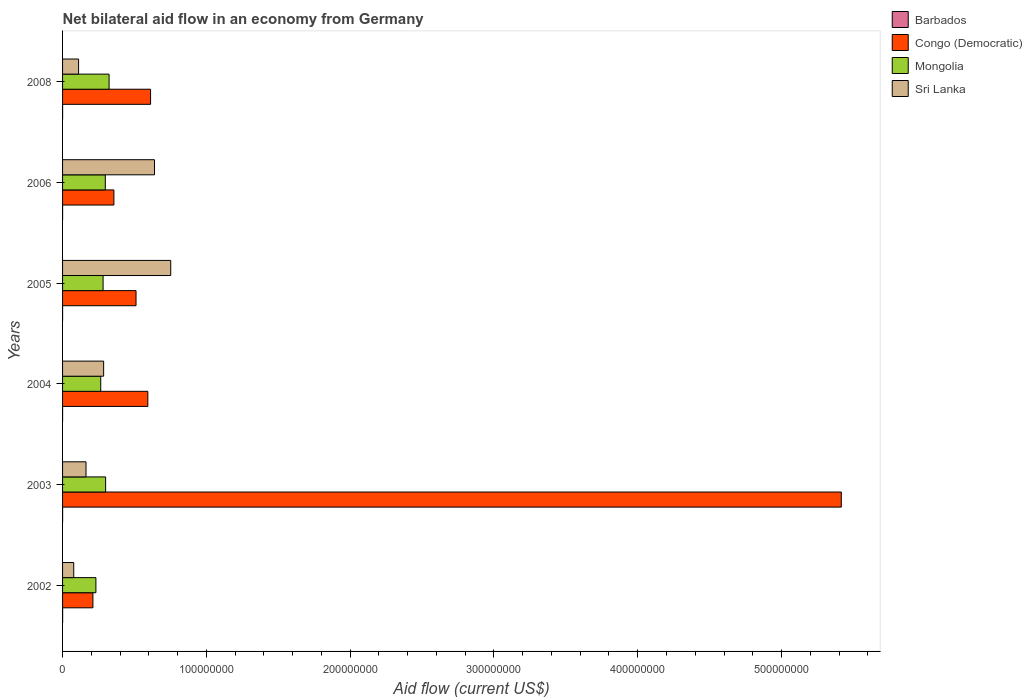How many different coloured bars are there?
Your response must be concise. 4. What is the net bilateral aid flow in Mongolia in 2004?
Keep it short and to the point. 2.65e+07. Across all years, what is the maximum net bilateral aid flow in Barbados?
Provide a succinct answer. 4.00e+04. Across all years, what is the minimum net bilateral aid flow in Congo (Democratic)?
Your answer should be compact. 2.11e+07. What is the total net bilateral aid flow in Mongolia in the graph?
Offer a very short reply. 1.70e+08. What is the difference between the net bilateral aid flow in Congo (Democratic) in 2005 and that in 2008?
Offer a very short reply. -1.01e+07. What is the difference between the net bilateral aid flow in Barbados in 2004 and the net bilateral aid flow in Congo (Democratic) in 2005?
Give a very brief answer. -5.11e+07. What is the average net bilateral aid flow in Sri Lanka per year?
Offer a very short reply. 3.38e+07. In the year 2006, what is the difference between the net bilateral aid flow in Mongolia and net bilateral aid flow in Barbados?
Your response must be concise. 2.97e+07. In how many years, is the net bilateral aid flow in Mongolia greater than 140000000 US$?
Keep it short and to the point. 0. What is the ratio of the net bilateral aid flow in Congo (Democratic) in 2004 to that in 2008?
Your response must be concise. 0.97. Is the net bilateral aid flow in Sri Lanka in 2003 less than that in 2004?
Offer a very short reply. Yes. Is the difference between the net bilateral aid flow in Mongolia in 2005 and 2008 greater than the difference between the net bilateral aid flow in Barbados in 2005 and 2008?
Give a very brief answer. No. What is the difference between the highest and the second highest net bilateral aid flow in Congo (Democratic)?
Keep it short and to the point. 4.80e+08. What is the difference between the highest and the lowest net bilateral aid flow in Mongolia?
Offer a terse response. 9.17e+06. In how many years, is the net bilateral aid flow in Barbados greater than the average net bilateral aid flow in Barbados taken over all years?
Keep it short and to the point. 2. Is it the case that in every year, the sum of the net bilateral aid flow in Congo (Democratic) and net bilateral aid flow in Mongolia is greater than the sum of net bilateral aid flow in Sri Lanka and net bilateral aid flow in Barbados?
Provide a short and direct response. Yes. What does the 3rd bar from the top in 2006 represents?
Keep it short and to the point. Congo (Democratic). What does the 1st bar from the bottom in 2002 represents?
Provide a succinct answer. Barbados. How many bars are there?
Provide a short and direct response. 24. How many years are there in the graph?
Provide a succinct answer. 6. Are the values on the major ticks of X-axis written in scientific E-notation?
Provide a succinct answer. No. Where does the legend appear in the graph?
Your answer should be compact. Top right. What is the title of the graph?
Make the answer very short. Net bilateral aid flow in an economy from Germany. What is the label or title of the X-axis?
Offer a very short reply. Aid flow (current US$). What is the Aid flow (current US$) in Barbados in 2002?
Give a very brief answer. 4.00e+04. What is the Aid flow (current US$) in Congo (Democratic) in 2002?
Ensure brevity in your answer.  2.11e+07. What is the Aid flow (current US$) of Mongolia in 2002?
Provide a succinct answer. 2.32e+07. What is the Aid flow (current US$) in Sri Lanka in 2002?
Provide a short and direct response. 7.77e+06. What is the Aid flow (current US$) of Congo (Democratic) in 2003?
Provide a short and direct response. 5.42e+08. What is the Aid flow (current US$) of Mongolia in 2003?
Your response must be concise. 2.99e+07. What is the Aid flow (current US$) in Sri Lanka in 2003?
Ensure brevity in your answer.  1.63e+07. What is the Aid flow (current US$) in Barbados in 2004?
Your response must be concise. 10000. What is the Aid flow (current US$) in Congo (Democratic) in 2004?
Offer a terse response. 5.93e+07. What is the Aid flow (current US$) in Mongolia in 2004?
Keep it short and to the point. 2.65e+07. What is the Aid flow (current US$) in Sri Lanka in 2004?
Give a very brief answer. 2.86e+07. What is the Aid flow (current US$) of Barbados in 2005?
Make the answer very short. 10000. What is the Aid flow (current US$) in Congo (Democratic) in 2005?
Keep it short and to the point. 5.11e+07. What is the Aid flow (current US$) of Mongolia in 2005?
Provide a short and direct response. 2.82e+07. What is the Aid flow (current US$) in Sri Lanka in 2005?
Your response must be concise. 7.52e+07. What is the Aid flow (current US$) of Congo (Democratic) in 2006?
Provide a succinct answer. 3.57e+07. What is the Aid flow (current US$) in Mongolia in 2006?
Offer a terse response. 2.97e+07. What is the Aid flow (current US$) in Sri Lanka in 2006?
Offer a very short reply. 6.39e+07. What is the Aid flow (current US$) of Congo (Democratic) in 2008?
Ensure brevity in your answer.  6.12e+07. What is the Aid flow (current US$) in Mongolia in 2008?
Your answer should be compact. 3.24e+07. What is the Aid flow (current US$) of Sri Lanka in 2008?
Provide a short and direct response. 1.11e+07. Across all years, what is the maximum Aid flow (current US$) of Congo (Democratic)?
Give a very brief answer. 5.42e+08. Across all years, what is the maximum Aid flow (current US$) of Mongolia?
Provide a succinct answer. 3.24e+07. Across all years, what is the maximum Aid flow (current US$) in Sri Lanka?
Your answer should be very brief. 7.52e+07. Across all years, what is the minimum Aid flow (current US$) of Barbados?
Your answer should be compact. 10000. Across all years, what is the minimum Aid flow (current US$) in Congo (Democratic)?
Provide a succinct answer. 2.11e+07. Across all years, what is the minimum Aid flow (current US$) of Mongolia?
Keep it short and to the point. 2.32e+07. Across all years, what is the minimum Aid flow (current US$) of Sri Lanka?
Give a very brief answer. 7.77e+06. What is the total Aid flow (current US$) in Congo (Democratic) in the graph?
Offer a terse response. 7.70e+08. What is the total Aid flow (current US$) of Mongolia in the graph?
Your response must be concise. 1.70e+08. What is the total Aid flow (current US$) of Sri Lanka in the graph?
Make the answer very short. 2.03e+08. What is the difference between the Aid flow (current US$) of Barbados in 2002 and that in 2003?
Give a very brief answer. 10000. What is the difference between the Aid flow (current US$) in Congo (Democratic) in 2002 and that in 2003?
Provide a succinct answer. -5.20e+08. What is the difference between the Aid flow (current US$) in Mongolia in 2002 and that in 2003?
Ensure brevity in your answer.  -6.75e+06. What is the difference between the Aid flow (current US$) of Sri Lanka in 2002 and that in 2003?
Your answer should be very brief. -8.54e+06. What is the difference between the Aid flow (current US$) of Congo (Democratic) in 2002 and that in 2004?
Ensure brevity in your answer.  -3.82e+07. What is the difference between the Aid flow (current US$) in Mongolia in 2002 and that in 2004?
Give a very brief answer. -3.35e+06. What is the difference between the Aid flow (current US$) of Sri Lanka in 2002 and that in 2004?
Your answer should be compact. -2.08e+07. What is the difference between the Aid flow (current US$) in Congo (Democratic) in 2002 and that in 2005?
Your answer should be compact. -3.00e+07. What is the difference between the Aid flow (current US$) of Mongolia in 2002 and that in 2005?
Offer a very short reply. -4.98e+06. What is the difference between the Aid flow (current US$) in Sri Lanka in 2002 and that in 2005?
Your response must be concise. -6.75e+07. What is the difference between the Aid flow (current US$) of Congo (Democratic) in 2002 and that in 2006?
Give a very brief answer. -1.46e+07. What is the difference between the Aid flow (current US$) in Mongolia in 2002 and that in 2006?
Offer a very short reply. -6.54e+06. What is the difference between the Aid flow (current US$) in Sri Lanka in 2002 and that in 2006?
Make the answer very short. -5.62e+07. What is the difference between the Aid flow (current US$) of Congo (Democratic) in 2002 and that in 2008?
Give a very brief answer. -4.01e+07. What is the difference between the Aid flow (current US$) in Mongolia in 2002 and that in 2008?
Make the answer very short. -9.17e+06. What is the difference between the Aid flow (current US$) in Sri Lanka in 2002 and that in 2008?
Ensure brevity in your answer.  -3.37e+06. What is the difference between the Aid flow (current US$) in Congo (Democratic) in 2003 and that in 2004?
Offer a very short reply. 4.82e+08. What is the difference between the Aid flow (current US$) in Mongolia in 2003 and that in 2004?
Provide a short and direct response. 3.40e+06. What is the difference between the Aid flow (current US$) in Sri Lanka in 2003 and that in 2004?
Give a very brief answer. -1.23e+07. What is the difference between the Aid flow (current US$) of Barbados in 2003 and that in 2005?
Offer a terse response. 2.00e+04. What is the difference between the Aid flow (current US$) in Congo (Democratic) in 2003 and that in 2005?
Keep it short and to the point. 4.90e+08. What is the difference between the Aid flow (current US$) in Mongolia in 2003 and that in 2005?
Provide a short and direct response. 1.77e+06. What is the difference between the Aid flow (current US$) of Sri Lanka in 2003 and that in 2005?
Make the answer very short. -5.89e+07. What is the difference between the Aid flow (current US$) in Congo (Democratic) in 2003 and that in 2006?
Provide a succinct answer. 5.06e+08. What is the difference between the Aid flow (current US$) of Mongolia in 2003 and that in 2006?
Provide a succinct answer. 2.10e+05. What is the difference between the Aid flow (current US$) in Sri Lanka in 2003 and that in 2006?
Keep it short and to the point. -4.76e+07. What is the difference between the Aid flow (current US$) in Congo (Democratic) in 2003 and that in 2008?
Keep it short and to the point. 4.80e+08. What is the difference between the Aid flow (current US$) in Mongolia in 2003 and that in 2008?
Keep it short and to the point. -2.42e+06. What is the difference between the Aid flow (current US$) in Sri Lanka in 2003 and that in 2008?
Offer a terse response. 5.17e+06. What is the difference between the Aid flow (current US$) of Barbados in 2004 and that in 2005?
Keep it short and to the point. 0. What is the difference between the Aid flow (current US$) in Congo (Democratic) in 2004 and that in 2005?
Your response must be concise. 8.20e+06. What is the difference between the Aid flow (current US$) of Mongolia in 2004 and that in 2005?
Provide a short and direct response. -1.63e+06. What is the difference between the Aid flow (current US$) in Sri Lanka in 2004 and that in 2005?
Offer a very short reply. -4.67e+07. What is the difference between the Aid flow (current US$) in Congo (Democratic) in 2004 and that in 2006?
Give a very brief answer. 2.36e+07. What is the difference between the Aid flow (current US$) in Mongolia in 2004 and that in 2006?
Keep it short and to the point. -3.19e+06. What is the difference between the Aid flow (current US$) in Sri Lanka in 2004 and that in 2006?
Keep it short and to the point. -3.54e+07. What is the difference between the Aid flow (current US$) in Barbados in 2004 and that in 2008?
Your response must be concise. -10000. What is the difference between the Aid flow (current US$) of Congo (Democratic) in 2004 and that in 2008?
Provide a succinct answer. -1.92e+06. What is the difference between the Aid flow (current US$) in Mongolia in 2004 and that in 2008?
Make the answer very short. -5.82e+06. What is the difference between the Aid flow (current US$) of Sri Lanka in 2004 and that in 2008?
Give a very brief answer. 1.74e+07. What is the difference between the Aid flow (current US$) in Barbados in 2005 and that in 2006?
Give a very brief answer. -10000. What is the difference between the Aid flow (current US$) of Congo (Democratic) in 2005 and that in 2006?
Keep it short and to the point. 1.54e+07. What is the difference between the Aid flow (current US$) of Mongolia in 2005 and that in 2006?
Keep it short and to the point. -1.56e+06. What is the difference between the Aid flow (current US$) in Sri Lanka in 2005 and that in 2006?
Keep it short and to the point. 1.13e+07. What is the difference between the Aid flow (current US$) in Congo (Democratic) in 2005 and that in 2008?
Give a very brief answer. -1.01e+07. What is the difference between the Aid flow (current US$) in Mongolia in 2005 and that in 2008?
Provide a short and direct response. -4.19e+06. What is the difference between the Aid flow (current US$) in Sri Lanka in 2005 and that in 2008?
Give a very brief answer. 6.41e+07. What is the difference between the Aid flow (current US$) of Congo (Democratic) in 2006 and that in 2008?
Your answer should be compact. -2.55e+07. What is the difference between the Aid flow (current US$) of Mongolia in 2006 and that in 2008?
Offer a terse response. -2.63e+06. What is the difference between the Aid flow (current US$) in Sri Lanka in 2006 and that in 2008?
Give a very brief answer. 5.28e+07. What is the difference between the Aid flow (current US$) in Barbados in 2002 and the Aid flow (current US$) in Congo (Democratic) in 2003?
Provide a short and direct response. -5.42e+08. What is the difference between the Aid flow (current US$) in Barbados in 2002 and the Aid flow (current US$) in Mongolia in 2003?
Your answer should be compact. -2.99e+07. What is the difference between the Aid flow (current US$) of Barbados in 2002 and the Aid flow (current US$) of Sri Lanka in 2003?
Ensure brevity in your answer.  -1.63e+07. What is the difference between the Aid flow (current US$) of Congo (Democratic) in 2002 and the Aid flow (current US$) of Mongolia in 2003?
Provide a succinct answer. -8.83e+06. What is the difference between the Aid flow (current US$) in Congo (Democratic) in 2002 and the Aid flow (current US$) in Sri Lanka in 2003?
Ensure brevity in your answer.  4.80e+06. What is the difference between the Aid flow (current US$) in Mongolia in 2002 and the Aid flow (current US$) in Sri Lanka in 2003?
Provide a short and direct response. 6.88e+06. What is the difference between the Aid flow (current US$) in Barbados in 2002 and the Aid flow (current US$) in Congo (Democratic) in 2004?
Your answer should be compact. -5.92e+07. What is the difference between the Aid flow (current US$) of Barbados in 2002 and the Aid flow (current US$) of Mongolia in 2004?
Ensure brevity in your answer.  -2.65e+07. What is the difference between the Aid flow (current US$) in Barbados in 2002 and the Aid flow (current US$) in Sri Lanka in 2004?
Provide a succinct answer. -2.85e+07. What is the difference between the Aid flow (current US$) in Congo (Democratic) in 2002 and the Aid flow (current US$) in Mongolia in 2004?
Offer a terse response. -5.43e+06. What is the difference between the Aid flow (current US$) of Congo (Democratic) in 2002 and the Aid flow (current US$) of Sri Lanka in 2004?
Provide a short and direct response. -7.46e+06. What is the difference between the Aid flow (current US$) of Mongolia in 2002 and the Aid flow (current US$) of Sri Lanka in 2004?
Your response must be concise. -5.38e+06. What is the difference between the Aid flow (current US$) of Barbados in 2002 and the Aid flow (current US$) of Congo (Democratic) in 2005?
Provide a short and direct response. -5.10e+07. What is the difference between the Aid flow (current US$) of Barbados in 2002 and the Aid flow (current US$) of Mongolia in 2005?
Ensure brevity in your answer.  -2.81e+07. What is the difference between the Aid flow (current US$) of Barbados in 2002 and the Aid flow (current US$) of Sri Lanka in 2005?
Your response must be concise. -7.52e+07. What is the difference between the Aid flow (current US$) in Congo (Democratic) in 2002 and the Aid flow (current US$) in Mongolia in 2005?
Your answer should be compact. -7.06e+06. What is the difference between the Aid flow (current US$) in Congo (Democratic) in 2002 and the Aid flow (current US$) in Sri Lanka in 2005?
Ensure brevity in your answer.  -5.41e+07. What is the difference between the Aid flow (current US$) of Mongolia in 2002 and the Aid flow (current US$) of Sri Lanka in 2005?
Provide a succinct answer. -5.20e+07. What is the difference between the Aid flow (current US$) in Barbados in 2002 and the Aid flow (current US$) in Congo (Democratic) in 2006?
Your answer should be very brief. -3.57e+07. What is the difference between the Aid flow (current US$) of Barbados in 2002 and the Aid flow (current US$) of Mongolia in 2006?
Offer a terse response. -2.97e+07. What is the difference between the Aid flow (current US$) of Barbados in 2002 and the Aid flow (current US$) of Sri Lanka in 2006?
Provide a short and direct response. -6.39e+07. What is the difference between the Aid flow (current US$) of Congo (Democratic) in 2002 and the Aid flow (current US$) of Mongolia in 2006?
Make the answer very short. -8.62e+06. What is the difference between the Aid flow (current US$) in Congo (Democratic) in 2002 and the Aid flow (current US$) in Sri Lanka in 2006?
Make the answer very short. -4.28e+07. What is the difference between the Aid flow (current US$) in Mongolia in 2002 and the Aid flow (current US$) in Sri Lanka in 2006?
Offer a very short reply. -4.08e+07. What is the difference between the Aid flow (current US$) of Barbados in 2002 and the Aid flow (current US$) of Congo (Democratic) in 2008?
Provide a succinct answer. -6.12e+07. What is the difference between the Aid flow (current US$) of Barbados in 2002 and the Aid flow (current US$) of Mongolia in 2008?
Offer a terse response. -3.23e+07. What is the difference between the Aid flow (current US$) of Barbados in 2002 and the Aid flow (current US$) of Sri Lanka in 2008?
Provide a succinct answer. -1.11e+07. What is the difference between the Aid flow (current US$) of Congo (Democratic) in 2002 and the Aid flow (current US$) of Mongolia in 2008?
Provide a short and direct response. -1.12e+07. What is the difference between the Aid flow (current US$) in Congo (Democratic) in 2002 and the Aid flow (current US$) in Sri Lanka in 2008?
Offer a terse response. 9.97e+06. What is the difference between the Aid flow (current US$) in Mongolia in 2002 and the Aid flow (current US$) in Sri Lanka in 2008?
Provide a succinct answer. 1.20e+07. What is the difference between the Aid flow (current US$) in Barbados in 2003 and the Aid flow (current US$) in Congo (Democratic) in 2004?
Provide a short and direct response. -5.93e+07. What is the difference between the Aid flow (current US$) in Barbados in 2003 and the Aid flow (current US$) in Mongolia in 2004?
Your answer should be very brief. -2.65e+07. What is the difference between the Aid flow (current US$) of Barbados in 2003 and the Aid flow (current US$) of Sri Lanka in 2004?
Your answer should be very brief. -2.85e+07. What is the difference between the Aid flow (current US$) in Congo (Democratic) in 2003 and the Aid flow (current US$) in Mongolia in 2004?
Your answer should be compact. 5.15e+08. What is the difference between the Aid flow (current US$) of Congo (Democratic) in 2003 and the Aid flow (current US$) of Sri Lanka in 2004?
Keep it short and to the point. 5.13e+08. What is the difference between the Aid flow (current US$) in Mongolia in 2003 and the Aid flow (current US$) in Sri Lanka in 2004?
Give a very brief answer. 1.37e+06. What is the difference between the Aid flow (current US$) of Barbados in 2003 and the Aid flow (current US$) of Congo (Democratic) in 2005?
Your answer should be very brief. -5.11e+07. What is the difference between the Aid flow (current US$) of Barbados in 2003 and the Aid flow (current US$) of Mongolia in 2005?
Give a very brief answer. -2.81e+07. What is the difference between the Aid flow (current US$) in Barbados in 2003 and the Aid flow (current US$) in Sri Lanka in 2005?
Your answer should be very brief. -7.52e+07. What is the difference between the Aid flow (current US$) of Congo (Democratic) in 2003 and the Aid flow (current US$) of Mongolia in 2005?
Your response must be concise. 5.13e+08. What is the difference between the Aid flow (current US$) of Congo (Democratic) in 2003 and the Aid flow (current US$) of Sri Lanka in 2005?
Provide a short and direct response. 4.66e+08. What is the difference between the Aid flow (current US$) of Mongolia in 2003 and the Aid flow (current US$) of Sri Lanka in 2005?
Your response must be concise. -4.53e+07. What is the difference between the Aid flow (current US$) of Barbados in 2003 and the Aid flow (current US$) of Congo (Democratic) in 2006?
Ensure brevity in your answer.  -3.57e+07. What is the difference between the Aid flow (current US$) of Barbados in 2003 and the Aid flow (current US$) of Mongolia in 2006?
Ensure brevity in your answer.  -2.97e+07. What is the difference between the Aid flow (current US$) in Barbados in 2003 and the Aid flow (current US$) in Sri Lanka in 2006?
Offer a terse response. -6.39e+07. What is the difference between the Aid flow (current US$) in Congo (Democratic) in 2003 and the Aid flow (current US$) in Mongolia in 2006?
Keep it short and to the point. 5.12e+08. What is the difference between the Aid flow (current US$) of Congo (Democratic) in 2003 and the Aid flow (current US$) of Sri Lanka in 2006?
Offer a terse response. 4.78e+08. What is the difference between the Aid flow (current US$) of Mongolia in 2003 and the Aid flow (current US$) of Sri Lanka in 2006?
Provide a succinct answer. -3.40e+07. What is the difference between the Aid flow (current US$) of Barbados in 2003 and the Aid flow (current US$) of Congo (Democratic) in 2008?
Offer a very short reply. -6.12e+07. What is the difference between the Aid flow (current US$) of Barbados in 2003 and the Aid flow (current US$) of Mongolia in 2008?
Your answer should be very brief. -3.23e+07. What is the difference between the Aid flow (current US$) of Barbados in 2003 and the Aid flow (current US$) of Sri Lanka in 2008?
Offer a very short reply. -1.11e+07. What is the difference between the Aid flow (current US$) of Congo (Democratic) in 2003 and the Aid flow (current US$) of Mongolia in 2008?
Make the answer very short. 5.09e+08. What is the difference between the Aid flow (current US$) in Congo (Democratic) in 2003 and the Aid flow (current US$) in Sri Lanka in 2008?
Give a very brief answer. 5.30e+08. What is the difference between the Aid flow (current US$) in Mongolia in 2003 and the Aid flow (current US$) in Sri Lanka in 2008?
Offer a very short reply. 1.88e+07. What is the difference between the Aid flow (current US$) in Barbados in 2004 and the Aid flow (current US$) in Congo (Democratic) in 2005?
Your answer should be very brief. -5.11e+07. What is the difference between the Aid flow (current US$) in Barbados in 2004 and the Aid flow (current US$) in Mongolia in 2005?
Keep it short and to the point. -2.82e+07. What is the difference between the Aid flow (current US$) in Barbados in 2004 and the Aid flow (current US$) in Sri Lanka in 2005?
Make the answer very short. -7.52e+07. What is the difference between the Aid flow (current US$) in Congo (Democratic) in 2004 and the Aid flow (current US$) in Mongolia in 2005?
Give a very brief answer. 3.11e+07. What is the difference between the Aid flow (current US$) of Congo (Democratic) in 2004 and the Aid flow (current US$) of Sri Lanka in 2005?
Your answer should be very brief. -1.59e+07. What is the difference between the Aid flow (current US$) in Mongolia in 2004 and the Aid flow (current US$) in Sri Lanka in 2005?
Offer a terse response. -4.87e+07. What is the difference between the Aid flow (current US$) of Barbados in 2004 and the Aid flow (current US$) of Congo (Democratic) in 2006?
Your answer should be very brief. -3.57e+07. What is the difference between the Aid flow (current US$) in Barbados in 2004 and the Aid flow (current US$) in Mongolia in 2006?
Your answer should be very brief. -2.97e+07. What is the difference between the Aid flow (current US$) of Barbados in 2004 and the Aid flow (current US$) of Sri Lanka in 2006?
Provide a succinct answer. -6.39e+07. What is the difference between the Aid flow (current US$) of Congo (Democratic) in 2004 and the Aid flow (current US$) of Mongolia in 2006?
Provide a succinct answer. 2.96e+07. What is the difference between the Aid flow (current US$) of Congo (Democratic) in 2004 and the Aid flow (current US$) of Sri Lanka in 2006?
Ensure brevity in your answer.  -4.65e+06. What is the difference between the Aid flow (current US$) of Mongolia in 2004 and the Aid flow (current US$) of Sri Lanka in 2006?
Ensure brevity in your answer.  -3.74e+07. What is the difference between the Aid flow (current US$) in Barbados in 2004 and the Aid flow (current US$) in Congo (Democratic) in 2008?
Keep it short and to the point. -6.12e+07. What is the difference between the Aid flow (current US$) in Barbados in 2004 and the Aid flow (current US$) in Mongolia in 2008?
Your answer should be compact. -3.24e+07. What is the difference between the Aid flow (current US$) in Barbados in 2004 and the Aid flow (current US$) in Sri Lanka in 2008?
Your answer should be compact. -1.11e+07. What is the difference between the Aid flow (current US$) in Congo (Democratic) in 2004 and the Aid flow (current US$) in Mongolia in 2008?
Provide a succinct answer. 2.69e+07. What is the difference between the Aid flow (current US$) of Congo (Democratic) in 2004 and the Aid flow (current US$) of Sri Lanka in 2008?
Your response must be concise. 4.82e+07. What is the difference between the Aid flow (current US$) in Mongolia in 2004 and the Aid flow (current US$) in Sri Lanka in 2008?
Make the answer very short. 1.54e+07. What is the difference between the Aid flow (current US$) in Barbados in 2005 and the Aid flow (current US$) in Congo (Democratic) in 2006?
Give a very brief answer. -3.57e+07. What is the difference between the Aid flow (current US$) of Barbados in 2005 and the Aid flow (current US$) of Mongolia in 2006?
Your answer should be compact. -2.97e+07. What is the difference between the Aid flow (current US$) of Barbados in 2005 and the Aid flow (current US$) of Sri Lanka in 2006?
Offer a terse response. -6.39e+07. What is the difference between the Aid flow (current US$) of Congo (Democratic) in 2005 and the Aid flow (current US$) of Mongolia in 2006?
Keep it short and to the point. 2.14e+07. What is the difference between the Aid flow (current US$) in Congo (Democratic) in 2005 and the Aid flow (current US$) in Sri Lanka in 2006?
Your answer should be very brief. -1.28e+07. What is the difference between the Aid flow (current US$) of Mongolia in 2005 and the Aid flow (current US$) of Sri Lanka in 2006?
Your answer should be compact. -3.58e+07. What is the difference between the Aid flow (current US$) in Barbados in 2005 and the Aid flow (current US$) in Congo (Democratic) in 2008?
Provide a short and direct response. -6.12e+07. What is the difference between the Aid flow (current US$) in Barbados in 2005 and the Aid flow (current US$) in Mongolia in 2008?
Your answer should be very brief. -3.24e+07. What is the difference between the Aid flow (current US$) in Barbados in 2005 and the Aid flow (current US$) in Sri Lanka in 2008?
Offer a terse response. -1.11e+07. What is the difference between the Aid flow (current US$) in Congo (Democratic) in 2005 and the Aid flow (current US$) in Mongolia in 2008?
Ensure brevity in your answer.  1.87e+07. What is the difference between the Aid flow (current US$) in Congo (Democratic) in 2005 and the Aid flow (current US$) in Sri Lanka in 2008?
Your response must be concise. 4.00e+07. What is the difference between the Aid flow (current US$) of Mongolia in 2005 and the Aid flow (current US$) of Sri Lanka in 2008?
Ensure brevity in your answer.  1.70e+07. What is the difference between the Aid flow (current US$) in Barbados in 2006 and the Aid flow (current US$) in Congo (Democratic) in 2008?
Provide a short and direct response. -6.12e+07. What is the difference between the Aid flow (current US$) of Barbados in 2006 and the Aid flow (current US$) of Mongolia in 2008?
Make the answer very short. -3.23e+07. What is the difference between the Aid flow (current US$) in Barbados in 2006 and the Aid flow (current US$) in Sri Lanka in 2008?
Give a very brief answer. -1.11e+07. What is the difference between the Aid flow (current US$) in Congo (Democratic) in 2006 and the Aid flow (current US$) in Mongolia in 2008?
Offer a terse response. 3.34e+06. What is the difference between the Aid flow (current US$) of Congo (Democratic) in 2006 and the Aid flow (current US$) of Sri Lanka in 2008?
Provide a short and direct response. 2.46e+07. What is the difference between the Aid flow (current US$) in Mongolia in 2006 and the Aid flow (current US$) in Sri Lanka in 2008?
Offer a very short reply. 1.86e+07. What is the average Aid flow (current US$) of Barbados per year?
Give a very brief answer. 2.17e+04. What is the average Aid flow (current US$) of Congo (Democratic) per year?
Give a very brief answer. 1.28e+08. What is the average Aid flow (current US$) in Mongolia per year?
Make the answer very short. 2.83e+07. What is the average Aid flow (current US$) of Sri Lanka per year?
Give a very brief answer. 3.38e+07. In the year 2002, what is the difference between the Aid flow (current US$) of Barbados and Aid flow (current US$) of Congo (Democratic)?
Provide a succinct answer. -2.11e+07. In the year 2002, what is the difference between the Aid flow (current US$) in Barbados and Aid flow (current US$) in Mongolia?
Keep it short and to the point. -2.32e+07. In the year 2002, what is the difference between the Aid flow (current US$) in Barbados and Aid flow (current US$) in Sri Lanka?
Your response must be concise. -7.73e+06. In the year 2002, what is the difference between the Aid flow (current US$) in Congo (Democratic) and Aid flow (current US$) in Mongolia?
Your response must be concise. -2.08e+06. In the year 2002, what is the difference between the Aid flow (current US$) of Congo (Democratic) and Aid flow (current US$) of Sri Lanka?
Make the answer very short. 1.33e+07. In the year 2002, what is the difference between the Aid flow (current US$) in Mongolia and Aid flow (current US$) in Sri Lanka?
Give a very brief answer. 1.54e+07. In the year 2003, what is the difference between the Aid flow (current US$) of Barbados and Aid flow (current US$) of Congo (Democratic)?
Provide a short and direct response. -5.42e+08. In the year 2003, what is the difference between the Aid flow (current US$) in Barbados and Aid flow (current US$) in Mongolia?
Provide a short and direct response. -2.99e+07. In the year 2003, what is the difference between the Aid flow (current US$) in Barbados and Aid flow (current US$) in Sri Lanka?
Your response must be concise. -1.63e+07. In the year 2003, what is the difference between the Aid flow (current US$) of Congo (Democratic) and Aid flow (current US$) of Mongolia?
Your answer should be very brief. 5.12e+08. In the year 2003, what is the difference between the Aid flow (current US$) in Congo (Democratic) and Aid flow (current US$) in Sri Lanka?
Your answer should be very brief. 5.25e+08. In the year 2003, what is the difference between the Aid flow (current US$) of Mongolia and Aid flow (current US$) of Sri Lanka?
Offer a very short reply. 1.36e+07. In the year 2004, what is the difference between the Aid flow (current US$) of Barbados and Aid flow (current US$) of Congo (Democratic)?
Provide a short and direct response. -5.93e+07. In the year 2004, what is the difference between the Aid flow (current US$) of Barbados and Aid flow (current US$) of Mongolia?
Provide a succinct answer. -2.65e+07. In the year 2004, what is the difference between the Aid flow (current US$) of Barbados and Aid flow (current US$) of Sri Lanka?
Provide a succinct answer. -2.86e+07. In the year 2004, what is the difference between the Aid flow (current US$) of Congo (Democratic) and Aid flow (current US$) of Mongolia?
Keep it short and to the point. 3.28e+07. In the year 2004, what is the difference between the Aid flow (current US$) in Congo (Democratic) and Aid flow (current US$) in Sri Lanka?
Your answer should be compact. 3.07e+07. In the year 2004, what is the difference between the Aid flow (current US$) in Mongolia and Aid flow (current US$) in Sri Lanka?
Ensure brevity in your answer.  -2.03e+06. In the year 2005, what is the difference between the Aid flow (current US$) of Barbados and Aid flow (current US$) of Congo (Democratic)?
Give a very brief answer. -5.11e+07. In the year 2005, what is the difference between the Aid flow (current US$) of Barbados and Aid flow (current US$) of Mongolia?
Your answer should be very brief. -2.82e+07. In the year 2005, what is the difference between the Aid flow (current US$) of Barbados and Aid flow (current US$) of Sri Lanka?
Keep it short and to the point. -7.52e+07. In the year 2005, what is the difference between the Aid flow (current US$) in Congo (Democratic) and Aid flow (current US$) in Mongolia?
Your answer should be very brief. 2.29e+07. In the year 2005, what is the difference between the Aid flow (current US$) in Congo (Democratic) and Aid flow (current US$) in Sri Lanka?
Offer a terse response. -2.41e+07. In the year 2005, what is the difference between the Aid flow (current US$) in Mongolia and Aid flow (current US$) in Sri Lanka?
Your response must be concise. -4.71e+07. In the year 2006, what is the difference between the Aid flow (current US$) of Barbados and Aid flow (current US$) of Congo (Democratic)?
Provide a short and direct response. -3.57e+07. In the year 2006, what is the difference between the Aid flow (current US$) in Barbados and Aid flow (current US$) in Mongolia?
Offer a very short reply. -2.97e+07. In the year 2006, what is the difference between the Aid flow (current US$) of Barbados and Aid flow (current US$) of Sri Lanka?
Ensure brevity in your answer.  -6.39e+07. In the year 2006, what is the difference between the Aid flow (current US$) of Congo (Democratic) and Aid flow (current US$) of Mongolia?
Give a very brief answer. 5.97e+06. In the year 2006, what is the difference between the Aid flow (current US$) of Congo (Democratic) and Aid flow (current US$) of Sri Lanka?
Make the answer very short. -2.82e+07. In the year 2006, what is the difference between the Aid flow (current US$) in Mongolia and Aid flow (current US$) in Sri Lanka?
Your response must be concise. -3.42e+07. In the year 2008, what is the difference between the Aid flow (current US$) of Barbados and Aid flow (current US$) of Congo (Democratic)?
Give a very brief answer. -6.12e+07. In the year 2008, what is the difference between the Aid flow (current US$) in Barbados and Aid flow (current US$) in Mongolia?
Keep it short and to the point. -3.23e+07. In the year 2008, what is the difference between the Aid flow (current US$) in Barbados and Aid flow (current US$) in Sri Lanka?
Make the answer very short. -1.11e+07. In the year 2008, what is the difference between the Aid flow (current US$) of Congo (Democratic) and Aid flow (current US$) of Mongolia?
Your response must be concise. 2.88e+07. In the year 2008, what is the difference between the Aid flow (current US$) in Congo (Democratic) and Aid flow (current US$) in Sri Lanka?
Give a very brief answer. 5.01e+07. In the year 2008, what is the difference between the Aid flow (current US$) in Mongolia and Aid flow (current US$) in Sri Lanka?
Your answer should be very brief. 2.12e+07. What is the ratio of the Aid flow (current US$) of Barbados in 2002 to that in 2003?
Provide a short and direct response. 1.33. What is the ratio of the Aid flow (current US$) in Congo (Democratic) in 2002 to that in 2003?
Offer a very short reply. 0.04. What is the ratio of the Aid flow (current US$) in Mongolia in 2002 to that in 2003?
Make the answer very short. 0.77. What is the ratio of the Aid flow (current US$) of Sri Lanka in 2002 to that in 2003?
Provide a succinct answer. 0.48. What is the ratio of the Aid flow (current US$) of Congo (Democratic) in 2002 to that in 2004?
Make the answer very short. 0.36. What is the ratio of the Aid flow (current US$) in Mongolia in 2002 to that in 2004?
Offer a very short reply. 0.87. What is the ratio of the Aid flow (current US$) of Sri Lanka in 2002 to that in 2004?
Give a very brief answer. 0.27. What is the ratio of the Aid flow (current US$) of Barbados in 2002 to that in 2005?
Offer a terse response. 4. What is the ratio of the Aid flow (current US$) in Congo (Democratic) in 2002 to that in 2005?
Offer a terse response. 0.41. What is the ratio of the Aid flow (current US$) of Mongolia in 2002 to that in 2005?
Make the answer very short. 0.82. What is the ratio of the Aid flow (current US$) of Sri Lanka in 2002 to that in 2005?
Keep it short and to the point. 0.1. What is the ratio of the Aid flow (current US$) in Congo (Democratic) in 2002 to that in 2006?
Your answer should be compact. 0.59. What is the ratio of the Aid flow (current US$) of Mongolia in 2002 to that in 2006?
Your response must be concise. 0.78. What is the ratio of the Aid flow (current US$) of Sri Lanka in 2002 to that in 2006?
Provide a succinct answer. 0.12. What is the ratio of the Aid flow (current US$) of Congo (Democratic) in 2002 to that in 2008?
Provide a succinct answer. 0.34. What is the ratio of the Aid flow (current US$) of Mongolia in 2002 to that in 2008?
Your response must be concise. 0.72. What is the ratio of the Aid flow (current US$) in Sri Lanka in 2002 to that in 2008?
Your answer should be very brief. 0.7. What is the ratio of the Aid flow (current US$) in Congo (Democratic) in 2003 to that in 2004?
Ensure brevity in your answer.  9.13. What is the ratio of the Aid flow (current US$) of Mongolia in 2003 to that in 2004?
Your answer should be very brief. 1.13. What is the ratio of the Aid flow (current US$) of Sri Lanka in 2003 to that in 2004?
Ensure brevity in your answer.  0.57. What is the ratio of the Aid flow (current US$) in Congo (Democratic) in 2003 to that in 2005?
Give a very brief answer. 10.6. What is the ratio of the Aid flow (current US$) in Mongolia in 2003 to that in 2005?
Offer a terse response. 1.06. What is the ratio of the Aid flow (current US$) of Sri Lanka in 2003 to that in 2005?
Your answer should be compact. 0.22. What is the ratio of the Aid flow (current US$) of Congo (Democratic) in 2003 to that in 2006?
Your answer should be compact. 15.17. What is the ratio of the Aid flow (current US$) in Mongolia in 2003 to that in 2006?
Your answer should be very brief. 1.01. What is the ratio of the Aid flow (current US$) in Sri Lanka in 2003 to that in 2006?
Offer a very short reply. 0.26. What is the ratio of the Aid flow (current US$) of Congo (Democratic) in 2003 to that in 2008?
Your answer should be very brief. 8.85. What is the ratio of the Aid flow (current US$) of Mongolia in 2003 to that in 2008?
Provide a short and direct response. 0.93. What is the ratio of the Aid flow (current US$) in Sri Lanka in 2003 to that in 2008?
Offer a terse response. 1.46. What is the ratio of the Aid flow (current US$) of Barbados in 2004 to that in 2005?
Your answer should be very brief. 1. What is the ratio of the Aid flow (current US$) of Congo (Democratic) in 2004 to that in 2005?
Give a very brief answer. 1.16. What is the ratio of the Aid flow (current US$) of Mongolia in 2004 to that in 2005?
Provide a succinct answer. 0.94. What is the ratio of the Aid flow (current US$) in Sri Lanka in 2004 to that in 2005?
Provide a short and direct response. 0.38. What is the ratio of the Aid flow (current US$) in Congo (Democratic) in 2004 to that in 2006?
Ensure brevity in your answer.  1.66. What is the ratio of the Aid flow (current US$) in Mongolia in 2004 to that in 2006?
Make the answer very short. 0.89. What is the ratio of the Aid flow (current US$) in Sri Lanka in 2004 to that in 2006?
Provide a succinct answer. 0.45. What is the ratio of the Aid flow (current US$) of Barbados in 2004 to that in 2008?
Offer a terse response. 0.5. What is the ratio of the Aid flow (current US$) of Congo (Democratic) in 2004 to that in 2008?
Your answer should be compact. 0.97. What is the ratio of the Aid flow (current US$) in Mongolia in 2004 to that in 2008?
Provide a short and direct response. 0.82. What is the ratio of the Aid flow (current US$) in Sri Lanka in 2004 to that in 2008?
Your response must be concise. 2.56. What is the ratio of the Aid flow (current US$) of Barbados in 2005 to that in 2006?
Offer a very short reply. 0.5. What is the ratio of the Aid flow (current US$) in Congo (Democratic) in 2005 to that in 2006?
Your answer should be very brief. 1.43. What is the ratio of the Aid flow (current US$) in Mongolia in 2005 to that in 2006?
Offer a very short reply. 0.95. What is the ratio of the Aid flow (current US$) of Sri Lanka in 2005 to that in 2006?
Make the answer very short. 1.18. What is the ratio of the Aid flow (current US$) in Barbados in 2005 to that in 2008?
Provide a succinct answer. 0.5. What is the ratio of the Aid flow (current US$) of Congo (Democratic) in 2005 to that in 2008?
Your answer should be compact. 0.83. What is the ratio of the Aid flow (current US$) of Mongolia in 2005 to that in 2008?
Offer a very short reply. 0.87. What is the ratio of the Aid flow (current US$) of Sri Lanka in 2005 to that in 2008?
Offer a terse response. 6.75. What is the ratio of the Aid flow (current US$) of Congo (Democratic) in 2006 to that in 2008?
Ensure brevity in your answer.  0.58. What is the ratio of the Aid flow (current US$) in Mongolia in 2006 to that in 2008?
Give a very brief answer. 0.92. What is the ratio of the Aid flow (current US$) of Sri Lanka in 2006 to that in 2008?
Your response must be concise. 5.74. What is the difference between the highest and the second highest Aid flow (current US$) of Barbados?
Offer a very short reply. 10000. What is the difference between the highest and the second highest Aid flow (current US$) in Congo (Democratic)?
Offer a terse response. 4.80e+08. What is the difference between the highest and the second highest Aid flow (current US$) of Mongolia?
Your answer should be compact. 2.42e+06. What is the difference between the highest and the second highest Aid flow (current US$) of Sri Lanka?
Offer a terse response. 1.13e+07. What is the difference between the highest and the lowest Aid flow (current US$) in Congo (Democratic)?
Offer a very short reply. 5.20e+08. What is the difference between the highest and the lowest Aid flow (current US$) in Mongolia?
Offer a terse response. 9.17e+06. What is the difference between the highest and the lowest Aid flow (current US$) of Sri Lanka?
Make the answer very short. 6.75e+07. 